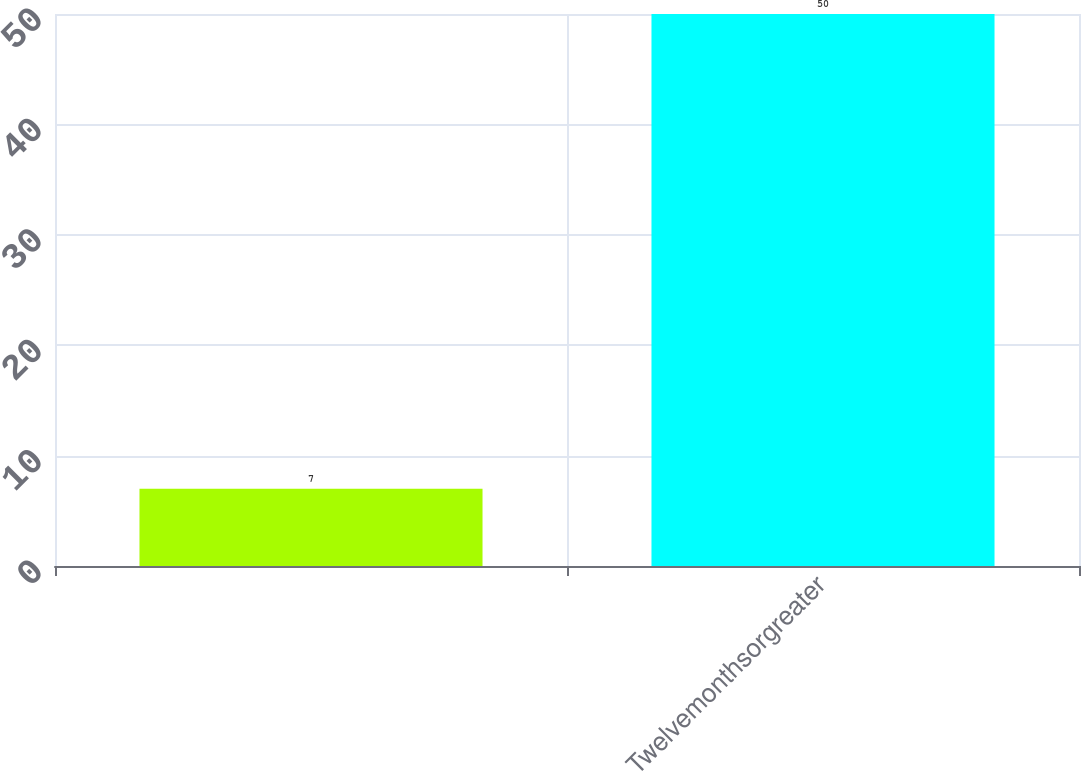<chart> <loc_0><loc_0><loc_500><loc_500><bar_chart><ecel><fcel>Twelvemonthsorgreater<nl><fcel>7<fcel>50<nl></chart> 